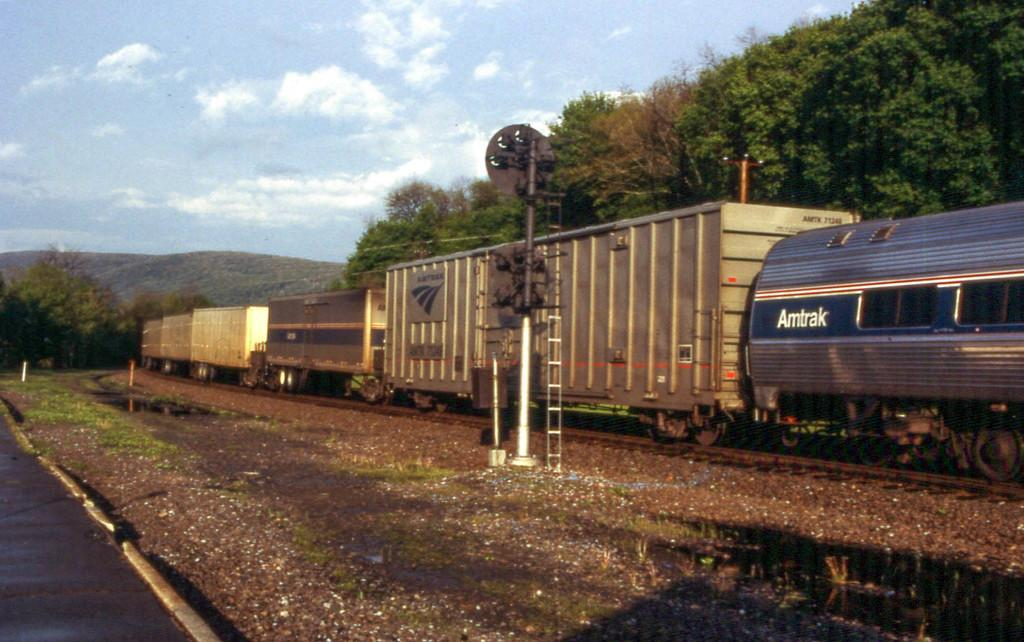What type of vehicle is in the image? There is a cargo train in the image. What is the train doing in the image? The train is moving on a track. What can be seen in the background of the image? There are trees visible in the background. What is located at the front bottom side of the image? There is a pole in the front bottom side of the image. What is visible beneath the train? The ground is visible in the image. How many frogs are hopping on the train in the image? There are no frogs present in the image; it features a cargo train moving on a track. What type of root can be seen growing from the train in the image? There is no root growing from the train in the image; it is a cargo train moving on a track. 